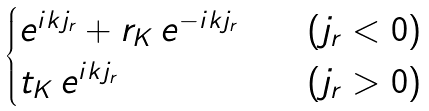<formula> <loc_0><loc_0><loc_500><loc_500>\begin{cases} e ^ { i k j _ { r } } + r _ { K } \, e ^ { - i k j _ { r } } \quad & ( j _ { r } < 0 ) \\ t _ { K } \, e ^ { i k j _ { r } } & ( j _ { r } > 0 ) \end{cases}</formula> 